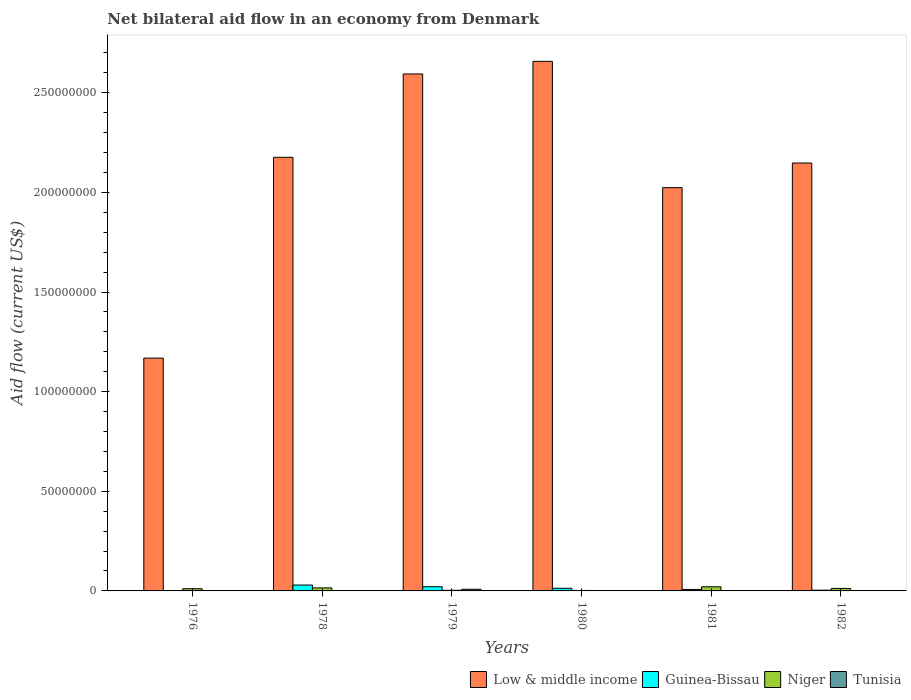How many different coloured bars are there?
Your answer should be very brief. 4. Are the number of bars per tick equal to the number of legend labels?
Make the answer very short. No. What is the label of the 1st group of bars from the left?
Provide a succinct answer. 1976. In how many cases, is the number of bars for a given year not equal to the number of legend labels?
Give a very brief answer. 4. What is the net bilateral aid flow in Niger in 1982?
Ensure brevity in your answer.  1.26e+06. Across all years, what is the maximum net bilateral aid flow in Tunisia?
Offer a very short reply. 8.40e+05. What is the total net bilateral aid flow in Low & middle income in the graph?
Your answer should be compact. 1.28e+09. What is the difference between the net bilateral aid flow in Low & middle income in 1981 and that in 1982?
Provide a succinct answer. -1.24e+07. What is the difference between the net bilateral aid flow in Low & middle income in 1982 and the net bilateral aid flow in Guinea-Bissau in 1980?
Ensure brevity in your answer.  2.13e+08. What is the average net bilateral aid flow in Low & middle income per year?
Give a very brief answer. 2.13e+08. In the year 1976, what is the difference between the net bilateral aid flow in Niger and net bilateral aid flow in Guinea-Bissau?
Your answer should be very brief. 1.02e+06. In how many years, is the net bilateral aid flow in Tunisia greater than 50000000 US$?
Offer a terse response. 0. What is the ratio of the net bilateral aid flow in Guinea-Bissau in 1976 to that in 1981?
Give a very brief answer. 0.11. Is the difference between the net bilateral aid flow in Niger in 1979 and 1982 greater than the difference between the net bilateral aid flow in Guinea-Bissau in 1979 and 1982?
Offer a terse response. No. What is the difference between the highest and the second highest net bilateral aid flow in Low & middle income?
Provide a succinct answer. 6.32e+06. What is the difference between the highest and the lowest net bilateral aid flow in Tunisia?
Your answer should be very brief. 8.40e+05. In how many years, is the net bilateral aid flow in Tunisia greater than the average net bilateral aid flow in Tunisia taken over all years?
Your response must be concise. 1. Is it the case that in every year, the sum of the net bilateral aid flow in Guinea-Bissau and net bilateral aid flow in Low & middle income is greater than the net bilateral aid flow in Niger?
Your answer should be very brief. Yes. Are all the bars in the graph horizontal?
Offer a terse response. No. Does the graph contain any zero values?
Make the answer very short. Yes. What is the title of the graph?
Make the answer very short. Net bilateral aid flow in an economy from Denmark. Does "Bulgaria" appear as one of the legend labels in the graph?
Your answer should be compact. No. What is the label or title of the X-axis?
Ensure brevity in your answer.  Years. What is the Aid flow (current US$) in Low & middle income in 1976?
Provide a succinct answer. 1.17e+08. What is the Aid flow (current US$) of Niger in 1976?
Offer a terse response. 1.10e+06. What is the Aid flow (current US$) in Low & middle income in 1978?
Offer a terse response. 2.18e+08. What is the Aid flow (current US$) in Guinea-Bissau in 1978?
Provide a succinct answer. 2.95e+06. What is the Aid flow (current US$) in Niger in 1978?
Your answer should be very brief. 1.52e+06. What is the Aid flow (current US$) in Tunisia in 1978?
Make the answer very short. 0. What is the Aid flow (current US$) of Low & middle income in 1979?
Give a very brief answer. 2.59e+08. What is the Aid flow (current US$) of Guinea-Bissau in 1979?
Make the answer very short. 2.11e+06. What is the Aid flow (current US$) in Tunisia in 1979?
Keep it short and to the point. 8.40e+05. What is the Aid flow (current US$) in Low & middle income in 1980?
Offer a terse response. 2.66e+08. What is the Aid flow (current US$) of Guinea-Bissau in 1980?
Your response must be concise. 1.33e+06. What is the Aid flow (current US$) in Low & middle income in 1981?
Ensure brevity in your answer.  2.02e+08. What is the Aid flow (current US$) of Guinea-Bissau in 1981?
Make the answer very short. 7.50e+05. What is the Aid flow (current US$) of Niger in 1981?
Offer a very short reply. 2.07e+06. What is the Aid flow (current US$) in Tunisia in 1981?
Keep it short and to the point. 0. What is the Aid flow (current US$) in Low & middle income in 1982?
Ensure brevity in your answer.  2.15e+08. What is the Aid flow (current US$) in Guinea-Bissau in 1982?
Provide a short and direct response. 3.70e+05. What is the Aid flow (current US$) in Niger in 1982?
Give a very brief answer. 1.26e+06. What is the Aid flow (current US$) of Tunisia in 1982?
Your answer should be very brief. 0. Across all years, what is the maximum Aid flow (current US$) of Low & middle income?
Provide a short and direct response. 2.66e+08. Across all years, what is the maximum Aid flow (current US$) in Guinea-Bissau?
Make the answer very short. 2.95e+06. Across all years, what is the maximum Aid flow (current US$) of Niger?
Your response must be concise. 2.07e+06. Across all years, what is the maximum Aid flow (current US$) of Tunisia?
Offer a very short reply. 8.40e+05. Across all years, what is the minimum Aid flow (current US$) of Low & middle income?
Provide a succinct answer. 1.17e+08. Across all years, what is the minimum Aid flow (current US$) in Guinea-Bissau?
Your answer should be very brief. 8.00e+04. What is the total Aid flow (current US$) in Low & middle income in the graph?
Ensure brevity in your answer.  1.28e+09. What is the total Aid flow (current US$) of Guinea-Bissau in the graph?
Your answer should be compact. 7.59e+06. What is the total Aid flow (current US$) of Niger in the graph?
Offer a very short reply. 6.48e+06. What is the total Aid flow (current US$) in Tunisia in the graph?
Offer a terse response. 1.00e+06. What is the difference between the Aid flow (current US$) of Low & middle income in 1976 and that in 1978?
Make the answer very short. -1.01e+08. What is the difference between the Aid flow (current US$) of Guinea-Bissau in 1976 and that in 1978?
Give a very brief answer. -2.87e+06. What is the difference between the Aid flow (current US$) of Niger in 1976 and that in 1978?
Offer a terse response. -4.20e+05. What is the difference between the Aid flow (current US$) of Low & middle income in 1976 and that in 1979?
Make the answer very short. -1.43e+08. What is the difference between the Aid flow (current US$) in Guinea-Bissau in 1976 and that in 1979?
Offer a terse response. -2.03e+06. What is the difference between the Aid flow (current US$) of Niger in 1976 and that in 1979?
Provide a succinct answer. 7.90e+05. What is the difference between the Aid flow (current US$) of Tunisia in 1976 and that in 1979?
Your answer should be very brief. -6.80e+05. What is the difference between the Aid flow (current US$) of Low & middle income in 1976 and that in 1980?
Your answer should be compact. -1.49e+08. What is the difference between the Aid flow (current US$) of Guinea-Bissau in 1976 and that in 1980?
Offer a very short reply. -1.25e+06. What is the difference between the Aid flow (current US$) of Niger in 1976 and that in 1980?
Your answer should be compact. 8.80e+05. What is the difference between the Aid flow (current US$) in Low & middle income in 1976 and that in 1981?
Your answer should be compact. -8.56e+07. What is the difference between the Aid flow (current US$) in Guinea-Bissau in 1976 and that in 1981?
Offer a terse response. -6.70e+05. What is the difference between the Aid flow (current US$) of Niger in 1976 and that in 1981?
Give a very brief answer. -9.70e+05. What is the difference between the Aid flow (current US$) of Low & middle income in 1976 and that in 1982?
Keep it short and to the point. -9.79e+07. What is the difference between the Aid flow (current US$) of Guinea-Bissau in 1976 and that in 1982?
Your answer should be very brief. -2.90e+05. What is the difference between the Aid flow (current US$) of Low & middle income in 1978 and that in 1979?
Provide a succinct answer. -4.18e+07. What is the difference between the Aid flow (current US$) in Guinea-Bissau in 1978 and that in 1979?
Give a very brief answer. 8.40e+05. What is the difference between the Aid flow (current US$) of Niger in 1978 and that in 1979?
Your response must be concise. 1.21e+06. What is the difference between the Aid flow (current US$) of Low & middle income in 1978 and that in 1980?
Ensure brevity in your answer.  -4.82e+07. What is the difference between the Aid flow (current US$) in Guinea-Bissau in 1978 and that in 1980?
Provide a succinct answer. 1.62e+06. What is the difference between the Aid flow (current US$) in Niger in 1978 and that in 1980?
Offer a very short reply. 1.30e+06. What is the difference between the Aid flow (current US$) of Low & middle income in 1978 and that in 1981?
Keep it short and to the point. 1.52e+07. What is the difference between the Aid flow (current US$) in Guinea-Bissau in 1978 and that in 1981?
Provide a succinct answer. 2.20e+06. What is the difference between the Aid flow (current US$) in Niger in 1978 and that in 1981?
Your answer should be very brief. -5.50e+05. What is the difference between the Aid flow (current US$) in Low & middle income in 1978 and that in 1982?
Provide a short and direct response. 2.86e+06. What is the difference between the Aid flow (current US$) of Guinea-Bissau in 1978 and that in 1982?
Keep it short and to the point. 2.58e+06. What is the difference between the Aid flow (current US$) in Niger in 1978 and that in 1982?
Offer a terse response. 2.60e+05. What is the difference between the Aid flow (current US$) in Low & middle income in 1979 and that in 1980?
Offer a very short reply. -6.32e+06. What is the difference between the Aid flow (current US$) of Guinea-Bissau in 1979 and that in 1980?
Provide a short and direct response. 7.80e+05. What is the difference between the Aid flow (current US$) in Niger in 1979 and that in 1980?
Your response must be concise. 9.00e+04. What is the difference between the Aid flow (current US$) in Low & middle income in 1979 and that in 1981?
Your answer should be very brief. 5.71e+07. What is the difference between the Aid flow (current US$) of Guinea-Bissau in 1979 and that in 1981?
Your answer should be compact. 1.36e+06. What is the difference between the Aid flow (current US$) in Niger in 1979 and that in 1981?
Ensure brevity in your answer.  -1.76e+06. What is the difference between the Aid flow (current US$) in Low & middle income in 1979 and that in 1982?
Offer a very short reply. 4.47e+07. What is the difference between the Aid flow (current US$) in Guinea-Bissau in 1979 and that in 1982?
Offer a very short reply. 1.74e+06. What is the difference between the Aid flow (current US$) in Niger in 1979 and that in 1982?
Offer a terse response. -9.50e+05. What is the difference between the Aid flow (current US$) of Low & middle income in 1980 and that in 1981?
Your response must be concise. 6.34e+07. What is the difference between the Aid flow (current US$) in Guinea-Bissau in 1980 and that in 1981?
Keep it short and to the point. 5.80e+05. What is the difference between the Aid flow (current US$) in Niger in 1980 and that in 1981?
Make the answer very short. -1.85e+06. What is the difference between the Aid flow (current US$) in Low & middle income in 1980 and that in 1982?
Keep it short and to the point. 5.10e+07. What is the difference between the Aid flow (current US$) in Guinea-Bissau in 1980 and that in 1982?
Provide a short and direct response. 9.60e+05. What is the difference between the Aid flow (current US$) of Niger in 1980 and that in 1982?
Your answer should be very brief. -1.04e+06. What is the difference between the Aid flow (current US$) of Low & middle income in 1981 and that in 1982?
Provide a short and direct response. -1.24e+07. What is the difference between the Aid flow (current US$) in Guinea-Bissau in 1981 and that in 1982?
Offer a very short reply. 3.80e+05. What is the difference between the Aid flow (current US$) in Niger in 1981 and that in 1982?
Your response must be concise. 8.10e+05. What is the difference between the Aid flow (current US$) of Low & middle income in 1976 and the Aid flow (current US$) of Guinea-Bissau in 1978?
Give a very brief answer. 1.14e+08. What is the difference between the Aid flow (current US$) of Low & middle income in 1976 and the Aid flow (current US$) of Niger in 1978?
Make the answer very short. 1.15e+08. What is the difference between the Aid flow (current US$) of Guinea-Bissau in 1976 and the Aid flow (current US$) of Niger in 1978?
Provide a short and direct response. -1.44e+06. What is the difference between the Aid flow (current US$) in Low & middle income in 1976 and the Aid flow (current US$) in Guinea-Bissau in 1979?
Keep it short and to the point. 1.15e+08. What is the difference between the Aid flow (current US$) of Low & middle income in 1976 and the Aid flow (current US$) of Niger in 1979?
Your answer should be compact. 1.17e+08. What is the difference between the Aid flow (current US$) of Low & middle income in 1976 and the Aid flow (current US$) of Tunisia in 1979?
Ensure brevity in your answer.  1.16e+08. What is the difference between the Aid flow (current US$) of Guinea-Bissau in 1976 and the Aid flow (current US$) of Tunisia in 1979?
Keep it short and to the point. -7.60e+05. What is the difference between the Aid flow (current US$) of Niger in 1976 and the Aid flow (current US$) of Tunisia in 1979?
Offer a terse response. 2.60e+05. What is the difference between the Aid flow (current US$) in Low & middle income in 1976 and the Aid flow (current US$) in Guinea-Bissau in 1980?
Offer a very short reply. 1.16e+08. What is the difference between the Aid flow (current US$) in Low & middle income in 1976 and the Aid flow (current US$) in Niger in 1980?
Your answer should be compact. 1.17e+08. What is the difference between the Aid flow (current US$) in Low & middle income in 1976 and the Aid flow (current US$) in Guinea-Bissau in 1981?
Your answer should be very brief. 1.16e+08. What is the difference between the Aid flow (current US$) of Low & middle income in 1976 and the Aid flow (current US$) of Niger in 1981?
Make the answer very short. 1.15e+08. What is the difference between the Aid flow (current US$) of Guinea-Bissau in 1976 and the Aid flow (current US$) of Niger in 1981?
Your response must be concise. -1.99e+06. What is the difference between the Aid flow (current US$) in Low & middle income in 1976 and the Aid flow (current US$) in Guinea-Bissau in 1982?
Make the answer very short. 1.16e+08. What is the difference between the Aid flow (current US$) of Low & middle income in 1976 and the Aid flow (current US$) of Niger in 1982?
Your response must be concise. 1.16e+08. What is the difference between the Aid flow (current US$) of Guinea-Bissau in 1976 and the Aid flow (current US$) of Niger in 1982?
Provide a short and direct response. -1.18e+06. What is the difference between the Aid flow (current US$) in Low & middle income in 1978 and the Aid flow (current US$) in Guinea-Bissau in 1979?
Provide a short and direct response. 2.16e+08. What is the difference between the Aid flow (current US$) of Low & middle income in 1978 and the Aid flow (current US$) of Niger in 1979?
Your answer should be very brief. 2.17e+08. What is the difference between the Aid flow (current US$) of Low & middle income in 1978 and the Aid flow (current US$) of Tunisia in 1979?
Ensure brevity in your answer.  2.17e+08. What is the difference between the Aid flow (current US$) in Guinea-Bissau in 1978 and the Aid flow (current US$) in Niger in 1979?
Offer a very short reply. 2.64e+06. What is the difference between the Aid flow (current US$) in Guinea-Bissau in 1978 and the Aid flow (current US$) in Tunisia in 1979?
Provide a short and direct response. 2.11e+06. What is the difference between the Aid flow (current US$) of Niger in 1978 and the Aid flow (current US$) of Tunisia in 1979?
Your response must be concise. 6.80e+05. What is the difference between the Aid flow (current US$) of Low & middle income in 1978 and the Aid flow (current US$) of Guinea-Bissau in 1980?
Ensure brevity in your answer.  2.16e+08. What is the difference between the Aid flow (current US$) in Low & middle income in 1978 and the Aid flow (current US$) in Niger in 1980?
Provide a succinct answer. 2.17e+08. What is the difference between the Aid flow (current US$) in Guinea-Bissau in 1978 and the Aid flow (current US$) in Niger in 1980?
Keep it short and to the point. 2.73e+06. What is the difference between the Aid flow (current US$) of Low & middle income in 1978 and the Aid flow (current US$) of Guinea-Bissau in 1981?
Keep it short and to the point. 2.17e+08. What is the difference between the Aid flow (current US$) in Low & middle income in 1978 and the Aid flow (current US$) in Niger in 1981?
Provide a short and direct response. 2.16e+08. What is the difference between the Aid flow (current US$) of Guinea-Bissau in 1978 and the Aid flow (current US$) of Niger in 1981?
Your response must be concise. 8.80e+05. What is the difference between the Aid flow (current US$) of Low & middle income in 1978 and the Aid flow (current US$) of Guinea-Bissau in 1982?
Ensure brevity in your answer.  2.17e+08. What is the difference between the Aid flow (current US$) in Low & middle income in 1978 and the Aid flow (current US$) in Niger in 1982?
Make the answer very short. 2.16e+08. What is the difference between the Aid flow (current US$) in Guinea-Bissau in 1978 and the Aid flow (current US$) in Niger in 1982?
Ensure brevity in your answer.  1.69e+06. What is the difference between the Aid flow (current US$) of Low & middle income in 1979 and the Aid flow (current US$) of Guinea-Bissau in 1980?
Provide a succinct answer. 2.58e+08. What is the difference between the Aid flow (current US$) of Low & middle income in 1979 and the Aid flow (current US$) of Niger in 1980?
Make the answer very short. 2.59e+08. What is the difference between the Aid flow (current US$) of Guinea-Bissau in 1979 and the Aid flow (current US$) of Niger in 1980?
Offer a terse response. 1.89e+06. What is the difference between the Aid flow (current US$) of Low & middle income in 1979 and the Aid flow (current US$) of Guinea-Bissau in 1981?
Your response must be concise. 2.59e+08. What is the difference between the Aid flow (current US$) of Low & middle income in 1979 and the Aid flow (current US$) of Niger in 1981?
Give a very brief answer. 2.57e+08. What is the difference between the Aid flow (current US$) of Low & middle income in 1979 and the Aid flow (current US$) of Guinea-Bissau in 1982?
Your answer should be compact. 2.59e+08. What is the difference between the Aid flow (current US$) of Low & middle income in 1979 and the Aid flow (current US$) of Niger in 1982?
Make the answer very short. 2.58e+08. What is the difference between the Aid flow (current US$) in Guinea-Bissau in 1979 and the Aid flow (current US$) in Niger in 1982?
Ensure brevity in your answer.  8.50e+05. What is the difference between the Aid flow (current US$) of Low & middle income in 1980 and the Aid flow (current US$) of Guinea-Bissau in 1981?
Ensure brevity in your answer.  2.65e+08. What is the difference between the Aid flow (current US$) in Low & middle income in 1980 and the Aid flow (current US$) in Niger in 1981?
Ensure brevity in your answer.  2.64e+08. What is the difference between the Aid flow (current US$) in Guinea-Bissau in 1980 and the Aid flow (current US$) in Niger in 1981?
Ensure brevity in your answer.  -7.40e+05. What is the difference between the Aid flow (current US$) in Low & middle income in 1980 and the Aid flow (current US$) in Guinea-Bissau in 1982?
Your answer should be very brief. 2.65e+08. What is the difference between the Aid flow (current US$) in Low & middle income in 1980 and the Aid flow (current US$) in Niger in 1982?
Provide a short and direct response. 2.65e+08. What is the difference between the Aid flow (current US$) in Guinea-Bissau in 1980 and the Aid flow (current US$) in Niger in 1982?
Provide a short and direct response. 7.00e+04. What is the difference between the Aid flow (current US$) in Low & middle income in 1981 and the Aid flow (current US$) in Guinea-Bissau in 1982?
Your answer should be compact. 2.02e+08. What is the difference between the Aid flow (current US$) of Low & middle income in 1981 and the Aid flow (current US$) of Niger in 1982?
Offer a very short reply. 2.01e+08. What is the difference between the Aid flow (current US$) of Guinea-Bissau in 1981 and the Aid flow (current US$) of Niger in 1982?
Provide a succinct answer. -5.10e+05. What is the average Aid flow (current US$) in Low & middle income per year?
Offer a terse response. 2.13e+08. What is the average Aid flow (current US$) of Guinea-Bissau per year?
Provide a succinct answer. 1.26e+06. What is the average Aid flow (current US$) of Niger per year?
Provide a succinct answer. 1.08e+06. What is the average Aid flow (current US$) of Tunisia per year?
Your answer should be very brief. 1.67e+05. In the year 1976, what is the difference between the Aid flow (current US$) of Low & middle income and Aid flow (current US$) of Guinea-Bissau?
Offer a very short reply. 1.17e+08. In the year 1976, what is the difference between the Aid flow (current US$) in Low & middle income and Aid flow (current US$) in Niger?
Provide a short and direct response. 1.16e+08. In the year 1976, what is the difference between the Aid flow (current US$) of Low & middle income and Aid flow (current US$) of Tunisia?
Keep it short and to the point. 1.17e+08. In the year 1976, what is the difference between the Aid flow (current US$) of Guinea-Bissau and Aid flow (current US$) of Niger?
Keep it short and to the point. -1.02e+06. In the year 1976, what is the difference between the Aid flow (current US$) in Niger and Aid flow (current US$) in Tunisia?
Provide a succinct answer. 9.40e+05. In the year 1978, what is the difference between the Aid flow (current US$) of Low & middle income and Aid flow (current US$) of Guinea-Bissau?
Ensure brevity in your answer.  2.15e+08. In the year 1978, what is the difference between the Aid flow (current US$) of Low & middle income and Aid flow (current US$) of Niger?
Keep it short and to the point. 2.16e+08. In the year 1978, what is the difference between the Aid flow (current US$) of Guinea-Bissau and Aid flow (current US$) of Niger?
Keep it short and to the point. 1.43e+06. In the year 1979, what is the difference between the Aid flow (current US$) of Low & middle income and Aid flow (current US$) of Guinea-Bissau?
Your answer should be very brief. 2.57e+08. In the year 1979, what is the difference between the Aid flow (current US$) in Low & middle income and Aid flow (current US$) in Niger?
Offer a terse response. 2.59e+08. In the year 1979, what is the difference between the Aid flow (current US$) in Low & middle income and Aid flow (current US$) in Tunisia?
Give a very brief answer. 2.59e+08. In the year 1979, what is the difference between the Aid flow (current US$) of Guinea-Bissau and Aid flow (current US$) of Niger?
Keep it short and to the point. 1.80e+06. In the year 1979, what is the difference between the Aid flow (current US$) of Guinea-Bissau and Aid flow (current US$) of Tunisia?
Your answer should be compact. 1.27e+06. In the year 1979, what is the difference between the Aid flow (current US$) of Niger and Aid flow (current US$) of Tunisia?
Provide a succinct answer. -5.30e+05. In the year 1980, what is the difference between the Aid flow (current US$) of Low & middle income and Aid flow (current US$) of Guinea-Bissau?
Offer a terse response. 2.64e+08. In the year 1980, what is the difference between the Aid flow (current US$) in Low & middle income and Aid flow (current US$) in Niger?
Make the answer very short. 2.66e+08. In the year 1980, what is the difference between the Aid flow (current US$) of Guinea-Bissau and Aid flow (current US$) of Niger?
Your response must be concise. 1.11e+06. In the year 1981, what is the difference between the Aid flow (current US$) of Low & middle income and Aid flow (current US$) of Guinea-Bissau?
Make the answer very short. 2.02e+08. In the year 1981, what is the difference between the Aid flow (current US$) in Low & middle income and Aid flow (current US$) in Niger?
Keep it short and to the point. 2.00e+08. In the year 1981, what is the difference between the Aid flow (current US$) of Guinea-Bissau and Aid flow (current US$) of Niger?
Your response must be concise. -1.32e+06. In the year 1982, what is the difference between the Aid flow (current US$) of Low & middle income and Aid flow (current US$) of Guinea-Bissau?
Make the answer very short. 2.14e+08. In the year 1982, what is the difference between the Aid flow (current US$) of Low & middle income and Aid flow (current US$) of Niger?
Offer a very short reply. 2.14e+08. In the year 1982, what is the difference between the Aid flow (current US$) of Guinea-Bissau and Aid flow (current US$) of Niger?
Offer a terse response. -8.90e+05. What is the ratio of the Aid flow (current US$) of Low & middle income in 1976 to that in 1978?
Make the answer very short. 0.54. What is the ratio of the Aid flow (current US$) of Guinea-Bissau in 1976 to that in 1978?
Your answer should be very brief. 0.03. What is the ratio of the Aid flow (current US$) of Niger in 1976 to that in 1978?
Make the answer very short. 0.72. What is the ratio of the Aid flow (current US$) in Low & middle income in 1976 to that in 1979?
Give a very brief answer. 0.45. What is the ratio of the Aid flow (current US$) in Guinea-Bissau in 1976 to that in 1979?
Offer a terse response. 0.04. What is the ratio of the Aid flow (current US$) in Niger in 1976 to that in 1979?
Ensure brevity in your answer.  3.55. What is the ratio of the Aid flow (current US$) in Tunisia in 1976 to that in 1979?
Provide a succinct answer. 0.19. What is the ratio of the Aid flow (current US$) of Low & middle income in 1976 to that in 1980?
Provide a succinct answer. 0.44. What is the ratio of the Aid flow (current US$) in Guinea-Bissau in 1976 to that in 1980?
Ensure brevity in your answer.  0.06. What is the ratio of the Aid flow (current US$) of Niger in 1976 to that in 1980?
Your answer should be compact. 5. What is the ratio of the Aid flow (current US$) in Low & middle income in 1976 to that in 1981?
Ensure brevity in your answer.  0.58. What is the ratio of the Aid flow (current US$) of Guinea-Bissau in 1976 to that in 1981?
Make the answer very short. 0.11. What is the ratio of the Aid flow (current US$) of Niger in 1976 to that in 1981?
Make the answer very short. 0.53. What is the ratio of the Aid flow (current US$) in Low & middle income in 1976 to that in 1982?
Give a very brief answer. 0.54. What is the ratio of the Aid flow (current US$) in Guinea-Bissau in 1976 to that in 1982?
Give a very brief answer. 0.22. What is the ratio of the Aid flow (current US$) of Niger in 1976 to that in 1982?
Keep it short and to the point. 0.87. What is the ratio of the Aid flow (current US$) in Low & middle income in 1978 to that in 1979?
Your response must be concise. 0.84. What is the ratio of the Aid flow (current US$) in Guinea-Bissau in 1978 to that in 1979?
Offer a terse response. 1.4. What is the ratio of the Aid flow (current US$) of Niger in 1978 to that in 1979?
Provide a short and direct response. 4.9. What is the ratio of the Aid flow (current US$) in Low & middle income in 1978 to that in 1980?
Make the answer very short. 0.82. What is the ratio of the Aid flow (current US$) in Guinea-Bissau in 1978 to that in 1980?
Make the answer very short. 2.22. What is the ratio of the Aid flow (current US$) in Niger in 1978 to that in 1980?
Your answer should be compact. 6.91. What is the ratio of the Aid flow (current US$) of Low & middle income in 1978 to that in 1981?
Give a very brief answer. 1.08. What is the ratio of the Aid flow (current US$) of Guinea-Bissau in 1978 to that in 1981?
Give a very brief answer. 3.93. What is the ratio of the Aid flow (current US$) in Niger in 1978 to that in 1981?
Ensure brevity in your answer.  0.73. What is the ratio of the Aid flow (current US$) in Low & middle income in 1978 to that in 1982?
Provide a succinct answer. 1.01. What is the ratio of the Aid flow (current US$) of Guinea-Bissau in 1978 to that in 1982?
Ensure brevity in your answer.  7.97. What is the ratio of the Aid flow (current US$) of Niger in 1978 to that in 1982?
Provide a succinct answer. 1.21. What is the ratio of the Aid flow (current US$) of Low & middle income in 1979 to that in 1980?
Ensure brevity in your answer.  0.98. What is the ratio of the Aid flow (current US$) of Guinea-Bissau in 1979 to that in 1980?
Provide a succinct answer. 1.59. What is the ratio of the Aid flow (current US$) of Niger in 1979 to that in 1980?
Provide a succinct answer. 1.41. What is the ratio of the Aid flow (current US$) in Low & middle income in 1979 to that in 1981?
Your answer should be compact. 1.28. What is the ratio of the Aid flow (current US$) of Guinea-Bissau in 1979 to that in 1981?
Make the answer very short. 2.81. What is the ratio of the Aid flow (current US$) of Niger in 1979 to that in 1981?
Your response must be concise. 0.15. What is the ratio of the Aid flow (current US$) of Low & middle income in 1979 to that in 1982?
Provide a short and direct response. 1.21. What is the ratio of the Aid flow (current US$) of Guinea-Bissau in 1979 to that in 1982?
Provide a short and direct response. 5.7. What is the ratio of the Aid flow (current US$) of Niger in 1979 to that in 1982?
Your answer should be very brief. 0.25. What is the ratio of the Aid flow (current US$) of Low & middle income in 1980 to that in 1981?
Keep it short and to the point. 1.31. What is the ratio of the Aid flow (current US$) of Guinea-Bissau in 1980 to that in 1981?
Offer a terse response. 1.77. What is the ratio of the Aid flow (current US$) of Niger in 1980 to that in 1981?
Provide a short and direct response. 0.11. What is the ratio of the Aid flow (current US$) of Low & middle income in 1980 to that in 1982?
Your answer should be compact. 1.24. What is the ratio of the Aid flow (current US$) in Guinea-Bissau in 1980 to that in 1982?
Your answer should be very brief. 3.59. What is the ratio of the Aid flow (current US$) of Niger in 1980 to that in 1982?
Provide a short and direct response. 0.17. What is the ratio of the Aid flow (current US$) of Low & middle income in 1981 to that in 1982?
Offer a terse response. 0.94. What is the ratio of the Aid flow (current US$) in Guinea-Bissau in 1981 to that in 1982?
Ensure brevity in your answer.  2.03. What is the ratio of the Aid flow (current US$) in Niger in 1981 to that in 1982?
Ensure brevity in your answer.  1.64. What is the difference between the highest and the second highest Aid flow (current US$) in Low & middle income?
Provide a short and direct response. 6.32e+06. What is the difference between the highest and the second highest Aid flow (current US$) of Guinea-Bissau?
Ensure brevity in your answer.  8.40e+05. What is the difference between the highest and the second highest Aid flow (current US$) of Niger?
Your response must be concise. 5.50e+05. What is the difference between the highest and the lowest Aid flow (current US$) in Low & middle income?
Offer a very short reply. 1.49e+08. What is the difference between the highest and the lowest Aid flow (current US$) in Guinea-Bissau?
Provide a succinct answer. 2.87e+06. What is the difference between the highest and the lowest Aid flow (current US$) in Niger?
Your response must be concise. 1.85e+06. What is the difference between the highest and the lowest Aid flow (current US$) in Tunisia?
Give a very brief answer. 8.40e+05. 